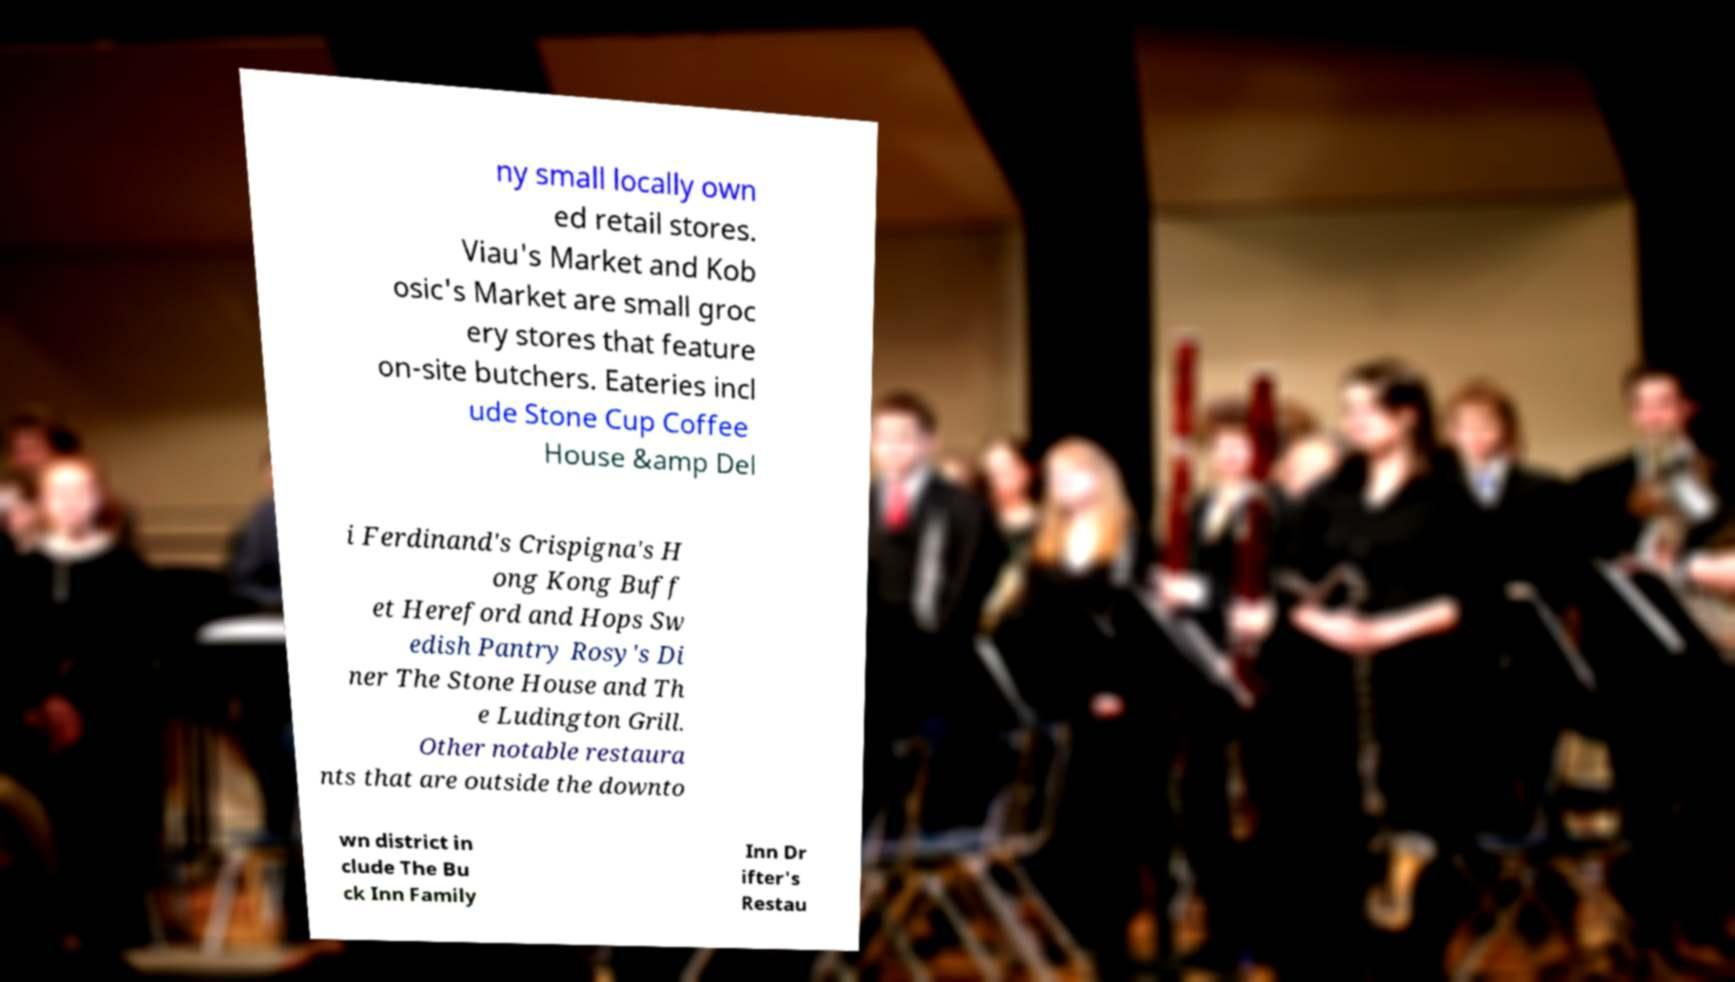Could you assist in decoding the text presented in this image and type it out clearly? ny small locally own ed retail stores. Viau's Market and Kob osic's Market are small groc ery stores that feature on-site butchers. Eateries incl ude Stone Cup Coffee House &amp Del i Ferdinand's Crispigna's H ong Kong Buff et Hereford and Hops Sw edish Pantry Rosy's Di ner The Stone House and Th e Ludington Grill. Other notable restaura nts that are outside the downto wn district in clude The Bu ck Inn Family Inn Dr ifter's Restau 